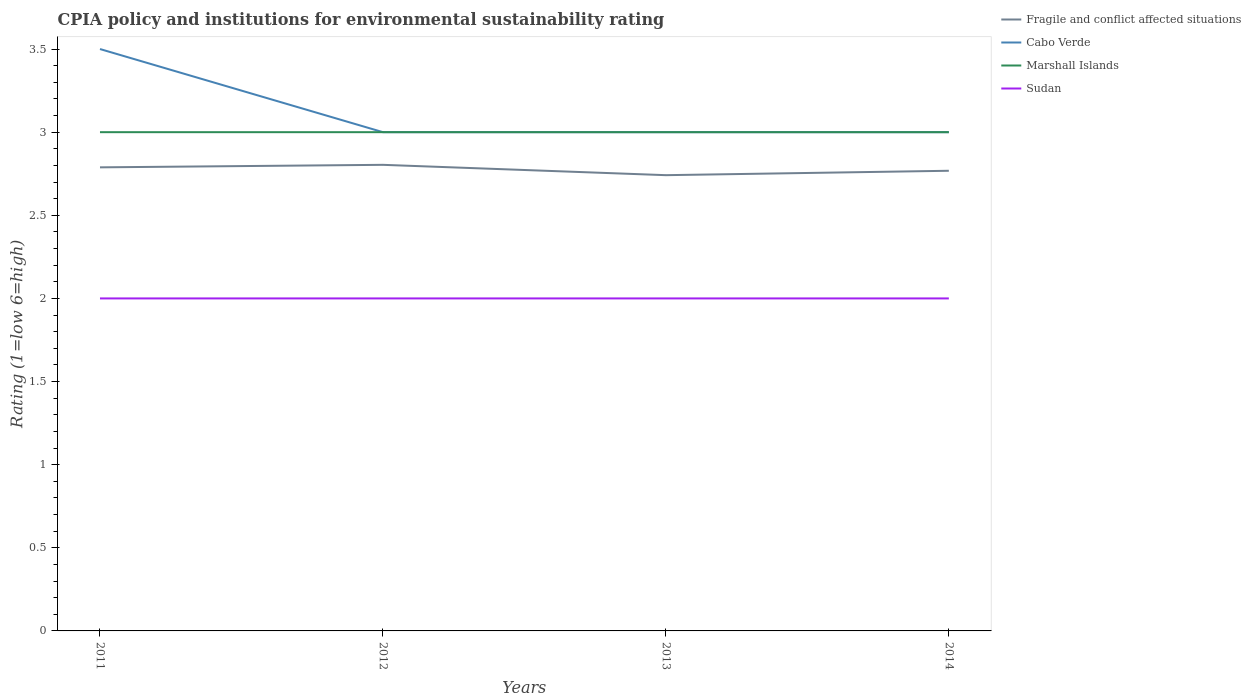Across all years, what is the maximum CPIA rating in Fragile and conflict affected situations?
Keep it short and to the point. 2.74. In which year was the CPIA rating in Cabo Verde maximum?
Provide a succinct answer. 2012. What is the total CPIA rating in Sudan in the graph?
Make the answer very short. 0. How many years are there in the graph?
Give a very brief answer. 4. What is the difference between two consecutive major ticks on the Y-axis?
Make the answer very short. 0.5. Does the graph contain grids?
Offer a very short reply. No. Where does the legend appear in the graph?
Give a very brief answer. Top right. How many legend labels are there?
Provide a succinct answer. 4. How are the legend labels stacked?
Your answer should be compact. Vertical. What is the title of the graph?
Your response must be concise. CPIA policy and institutions for environmental sustainability rating. What is the label or title of the X-axis?
Keep it short and to the point. Years. What is the label or title of the Y-axis?
Your response must be concise. Rating (1=low 6=high). What is the Rating (1=low 6=high) in Fragile and conflict affected situations in 2011?
Give a very brief answer. 2.79. What is the Rating (1=low 6=high) of Marshall Islands in 2011?
Keep it short and to the point. 3. What is the Rating (1=low 6=high) in Sudan in 2011?
Your answer should be compact. 2. What is the Rating (1=low 6=high) in Fragile and conflict affected situations in 2012?
Ensure brevity in your answer.  2.8. What is the Rating (1=low 6=high) in Cabo Verde in 2012?
Your answer should be very brief. 3. What is the Rating (1=low 6=high) in Marshall Islands in 2012?
Keep it short and to the point. 3. What is the Rating (1=low 6=high) in Fragile and conflict affected situations in 2013?
Offer a very short reply. 2.74. What is the Rating (1=low 6=high) of Fragile and conflict affected situations in 2014?
Provide a short and direct response. 2.77. Across all years, what is the maximum Rating (1=low 6=high) in Fragile and conflict affected situations?
Your response must be concise. 2.8. Across all years, what is the maximum Rating (1=low 6=high) in Marshall Islands?
Your answer should be very brief. 3. Across all years, what is the maximum Rating (1=low 6=high) in Sudan?
Ensure brevity in your answer.  2. Across all years, what is the minimum Rating (1=low 6=high) in Fragile and conflict affected situations?
Keep it short and to the point. 2.74. Across all years, what is the minimum Rating (1=low 6=high) of Marshall Islands?
Keep it short and to the point. 3. Across all years, what is the minimum Rating (1=low 6=high) of Sudan?
Give a very brief answer. 2. What is the total Rating (1=low 6=high) in Fragile and conflict affected situations in the graph?
Your answer should be very brief. 11.1. What is the total Rating (1=low 6=high) in Marshall Islands in the graph?
Provide a succinct answer. 12. What is the difference between the Rating (1=low 6=high) of Fragile and conflict affected situations in 2011 and that in 2012?
Offer a very short reply. -0.02. What is the difference between the Rating (1=low 6=high) of Marshall Islands in 2011 and that in 2012?
Your answer should be compact. 0. What is the difference between the Rating (1=low 6=high) of Sudan in 2011 and that in 2012?
Give a very brief answer. 0. What is the difference between the Rating (1=low 6=high) in Fragile and conflict affected situations in 2011 and that in 2013?
Your answer should be compact. 0.05. What is the difference between the Rating (1=low 6=high) in Marshall Islands in 2011 and that in 2013?
Offer a terse response. 0. What is the difference between the Rating (1=low 6=high) of Fragile and conflict affected situations in 2011 and that in 2014?
Make the answer very short. 0.02. What is the difference between the Rating (1=low 6=high) in Cabo Verde in 2011 and that in 2014?
Your answer should be compact. 0.5. What is the difference between the Rating (1=low 6=high) in Marshall Islands in 2011 and that in 2014?
Offer a very short reply. 0. What is the difference between the Rating (1=low 6=high) in Fragile and conflict affected situations in 2012 and that in 2013?
Ensure brevity in your answer.  0.06. What is the difference between the Rating (1=low 6=high) of Cabo Verde in 2012 and that in 2013?
Offer a very short reply. 0. What is the difference between the Rating (1=low 6=high) of Marshall Islands in 2012 and that in 2013?
Provide a succinct answer. 0. What is the difference between the Rating (1=low 6=high) in Sudan in 2012 and that in 2013?
Your response must be concise. 0. What is the difference between the Rating (1=low 6=high) in Fragile and conflict affected situations in 2012 and that in 2014?
Offer a terse response. 0.04. What is the difference between the Rating (1=low 6=high) in Cabo Verde in 2012 and that in 2014?
Your answer should be very brief. 0. What is the difference between the Rating (1=low 6=high) of Sudan in 2012 and that in 2014?
Offer a terse response. 0. What is the difference between the Rating (1=low 6=high) of Fragile and conflict affected situations in 2013 and that in 2014?
Offer a very short reply. -0.03. What is the difference between the Rating (1=low 6=high) in Marshall Islands in 2013 and that in 2014?
Give a very brief answer. 0. What is the difference between the Rating (1=low 6=high) of Fragile and conflict affected situations in 2011 and the Rating (1=low 6=high) of Cabo Verde in 2012?
Your response must be concise. -0.21. What is the difference between the Rating (1=low 6=high) of Fragile and conflict affected situations in 2011 and the Rating (1=low 6=high) of Marshall Islands in 2012?
Offer a terse response. -0.21. What is the difference between the Rating (1=low 6=high) in Fragile and conflict affected situations in 2011 and the Rating (1=low 6=high) in Sudan in 2012?
Ensure brevity in your answer.  0.79. What is the difference between the Rating (1=low 6=high) of Cabo Verde in 2011 and the Rating (1=low 6=high) of Marshall Islands in 2012?
Your answer should be compact. 0.5. What is the difference between the Rating (1=low 6=high) in Cabo Verde in 2011 and the Rating (1=low 6=high) in Sudan in 2012?
Your answer should be compact. 1.5. What is the difference between the Rating (1=low 6=high) in Marshall Islands in 2011 and the Rating (1=low 6=high) in Sudan in 2012?
Make the answer very short. 1. What is the difference between the Rating (1=low 6=high) in Fragile and conflict affected situations in 2011 and the Rating (1=low 6=high) in Cabo Verde in 2013?
Offer a very short reply. -0.21. What is the difference between the Rating (1=low 6=high) of Fragile and conflict affected situations in 2011 and the Rating (1=low 6=high) of Marshall Islands in 2013?
Make the answer very short. -0.21. What is the difference between the Rating (1=low 6=high) of Fragile and conflict affected situations in 2011 and the Rating (1=low 6=high) of Sudan in 2013?
Offer a very short reply. 0.79. What is the difference between the Rating (1=low 6=high) in Cabo Verde in 2011 and the Rating (1=low 6=high) in Sudan in 2013?
Your answer should be compact. 1.5. What is the difference between the Rating (1=low 6=high) of Marshall Islands in 2011 and the Rating (1=low 6=high) of Sudan in 2013?
Offer a very short reply. 1. What is the difference between the Rating (1=low 6=high) of Fragile and conflict affected situations in 2011 and the Rating (1=low 6=high) of Cabo Verde in 2014?
Offer a very short reply. -0.21. What is the difference between the Rating (1=low 6=high) of Fragile and conflict affected situations in 2011 and the Rating (1=low 6=high) of Marshall Islands in 2014?
Offer a terse response. -0.21. What is the difference between the Rating (1=low 6=high) of Fragile and conflict affected situations in 2011 and the Rating (1=low 6=high) of Sudan in 2014?
Your response must be concise. 0.79. What is the difference between the Rating (1=low 6=high) in Cabo Verde in 2011 and the Rating (1=low 6=high) in Marshall Islands in 2014?
Offer a terse response. 0.5. What is the difference between the Rating (1=low 6=high) in Marshall Islands in 2011 and the Rating (1=low 6=high) in Sudan in 2014?
Your answer should be very brief. 1. What is the difference between the Rating (1=low 6=high) of Fragile and conflict affected situations in 2012 and the Rating (1=low 6=high) of Cabo Verde in 2013?
Your answer should be very brief. -0.2. What is the difference between the Rating (1=low 6=high) of Fragile and conflict affected situations in 2012 and the Rating (1=low 6=high) of Marshall Islands in 2013?
Your response must be concise. -0.2. What is the difference between the Rating (1=low 6=high) in Fragile and conflict affected situations in 2012 and the Rating (1=low 6=high) in Sudan in 2013?
Your answer should be compact. 0.8. What is the difference between the Rating (1=low 6=high) in Cabo Verde in 2012 and the Rating (1=low 6=high) in Marshall Islands in 2013?
Your response must be concise. 0. What is the difference between the Rating (1=low 6=high) of Cabo Verde in 2012 and the Rating (1=low 6=high) of Sudan in 2013?
Provide a succinct answer. 1. What is the difference between the Rating (1=low 6=high) of Marshall Islands in 2012 and the Rating (1=low 6=high) of Sudan in 2013?
Your answer should be compact. 1. What is the difference between the Rating (1=low 6=high) in Fragile and conflict affected situations in 2012 and the Rating (1=low 6=high) in Cabo Verde in 2014?
Keep it short and to the point. -0.2. What is the difference between the Rating (1=low 6=high) of Fragile and conflict affected situations in 2012 and the Rating (1=low 6=high) of Marshall Islands in 2014?
Offer a terse response. -0.2. What is the difference between the Rating (1=low 6=high) of Fragile and conflict affected situations in 2012 and the Rating (1=low 6=high) of Sudan in 2014?
Ensure brevity in your answer.  0.8. What is the difference between the Rating (1=low 6=high) of Cabo Verde in 2012 and the Rating (1=low 6=high) of Marshall Islands in 2014?
Your answer should be very brief. 0. What is the difference between the Rating (1=low 6=high) in Cabo Verde in 2012 and the Rating (1=low 6=high) in Sudan in 2014?
Provide a succinct answer. 1. What is the difference between the Rating (1=low 6=high) in Fragile and conflict affected situations in 2013 and the Rating (1=low 6=high) in Cabo Verde in 2014?
Your response must be concise. -0.26. What is the difference between the Rating (1=low 6=high) in Fragile and conflict affected situations in 2013 and the Rating (1=low 6=high) in Marshall Islands in 2014?
Keep it short and to the point. -0.26. What is the difference between the Rating (1=low 6=high) of Fragile and conflict affected situations in 2013 and the Rating (1=low 6=high) of Sudan in 2014?
Provide a short and direct response. 0.74. What is the average Rating (1=low 6=high) of Fragile and conflict affected situations per year?
Your answer should be very brief. 2.78. What is the average Rating (1=low 6=high) in Cabo Verde per year?
Your answer should be very brief. 3.12. What is the average Rating (1=low 6=high) of Sudan per year?
Your response must be concise. 2. In the year 2011, what is the difference between the Rating (1=low 6=high) of Fragile and conflict affected situations and Rating (1=low 6=high) of Cabo Verde?
Provide a short and direct response. -0.71. In the year 2011, what is the difference between the Rating (1=low 6=high) of Fragile and conflict affected situations and Rating (1=low 6=high) of Marshall Islands?
Your answer should be compact. -0.21. In the year 2011, what is the difference between the Rating (1=low 6=high) in Fragile and conflict affected situations and Rating (1=low 6=high) in Sudan?
Keep it short and to the point. 0.79. In the year 2011, what is the difference between the Rating (1=low 6=high) in Cabo Verde and Rating (1=low 6=high) in Marshall Islands?
Ensure brevity in your answer.  0.5. In the year 2012, what is the difference between the Rating (1=low 6=high) in Fragile and conflict affected situations and Rating (1=low 6=high) in Cabo Verde?
Give a very brief answer. -0.2. In the year 2012, what is the difference between the Rating (1=low 6=high) in Fragile and conflict affected situations and Rating (1=low 6=high) in Marshall Islands?
Your answer should be compact. -0.2. In the year 2012, what is the difference between the Rating (1=low 6=high) in Fragile and conflict affected situations and Rating (1=low 6=high) in Sudan?
Give a very brief answer. 0.8. In the year 2012, what is the difference between the Rating (1=low 6=high) in Cabo Verde and Rating (1=low 6=high) in Sudan?
Keep it short and to the point. 1. In the year 2012, what is the difference between the Rating (1=low 6=high) in Marshall Islands and Rating (1=low 6=high) in Sudan?
Give a very brief answer. 1. In the year 2013, what is the difference between the Rating (1=low 6=high) in Fragile and conflict affected situations and Rating (1=low 6=high) in Cabo Verde?
Your response must be concise. -0.26. In the year 2013, what is the difference between the Rating (1=low 6=high) in Fragile and conflict affected situations and Rating (1=low 6=high) in Marshall Islands?
Give a very brief answer. -0.26. In the year 2013, what is the difference between the Rating (1=low 6=high) of Fragile and conflict affected situations and Rating (1=low 6=high) of Sudan?
Give a very brief answer. 0.74. In the year 2013, what is the difference between the Rating (1=low 6=high) of Cabo Verde and Rating (1=low 6=high) of Marshall Islands?
Make the answer very short. 0. In the year 2013, what is the difference between the Rating (1=low 6=high) in Cabo Verde and Rating (1=low 6=high) in Sudan?
Provide a short and direct response. 1. In the year 2013, what is the difference between the Rating (1=low 6=high) of Marshall Islands and Rating (1=low 6=high) of Sudan?
Keep it short and to the point. 1. In the year 2014, what is the difference between the Rating (1=low 6=high) of Fragile and conflict affected situations and Rating (1=low 6=high) of Cabo Verde?
Your answer should be very brief. -0.23. In the year 2014, what is the difference between the Rating (1=low 6=high) in Fragile and conflict affected situations and Rating (1=low 6=high) in Marshall Islands?
Give a very brief answer. -0.23. In the year 2014, what is the difference between the Rating (1=low 6=high) in Fragile and conflict affected situations and Rating (1=low 6=high) in Sudan?
Offer a very short reply. 0.77. In the year 2014, what is the difference between the Rating (1=low 6=high) of Cabo Verde and Rating (1=low 6=high) of Marshall Islands?
Your answer should be very brief. 0. What is the ratio of the Rating (1=low 6=high) in Fragile and conflict affected situations in 2011 to that in 2012?
Provide a short and direct response. 0.99. What is the ratio of the Rating (1=low 6=high) of Sudan in 2011 to that in 2012?
Offer a very short reply. 1. What is the ratio of the Rating (1=low 6=high) of Fragile and conflict affected situations in 2011 to that in 2013?
Your response must be concise. 1.02. What is the ratio of the Rating (1=low 6=high) of Marshall Islands in 2011 to that in 2013?
Keep it short and to the point. 1. What is the ratio of the Rating (1=low 6=high) in Sudan in 2011 to that in 2013?
Keep it short and to the point. 1. What is the ratio of the Rating (1=low 6=high) of Fragile and conflict affected situations in 2011 to that in 2014?
Your answer should be very brief. 1.01. What is the ratio of the Rating (1=low 6=high) of Sudan in 2011 to that in 2014?
Give a very brief answer. 1. What is the ratio of the Rating (1=low 6=high) in Fragile and conflict affected situations in 2012 to that in 2013?
Your answer should be compact. 1.02. What is the ratio of the Rating (1=low 6=high) of Marshall Islands in 2012 to that in 2013?
Offer a very short reply. 1. What is the ratio of the Rating (1=low 6=high) of Sudan in 2012 to that in 2013?
Give a very brief answer. 1. What is the ratio of the Rating (1=low 6=high) in Fragile and conflict affected situations in 2012 to that in 2014?
Give a very brief answer. 1.01. What is the ratio of the Rating (1=low 6=high) in Cabo Verde in 2012 to that in 2014?
Provide a short and direct response. 1. What is the ratio of the Rating (1=low 6=high) in Fragile and conflict affected situations in 2013 to that in 2014?
Provide a short and direct response. 0.99. What is the ratio of the Rating (1=low 6=high) of Cabo Verde in 2013 to that in 2014?
Your answer should be compact. 1. What is the ratio of the Rating (1=low 6=high) of Marshall Islands in 2013 to that in 2014?
Provide a short and direct response. 1. What is the difference between the highest and the second highest Rating (1=low 6=high) in Fragile and conflict affected situations?
Keep it short and to the point. 0.02. What is the difference between the highest and the second highest Rating (1=low 6=high) of Cabo Verde?
Provide a succinct answer. 0.5. What is the difference between the highest and the second highest Rating (1=low 6=high) of Marshall Islands?
Keep it short and to the point. 0. What is the difference between the highest and the lowest Rating (1=low 6=high) in Fragile and conflict affected situations?
Offer a very short reply. 0.06. What is the difference between the highest and the lowest Rating (1=low 6=high) of Cabo Verde?
Give a very brief answer. 0.5. What is the difference between the highest and the lowest Rating (1=low 6=high) of Sudan?
Your response must be concise. 0. 